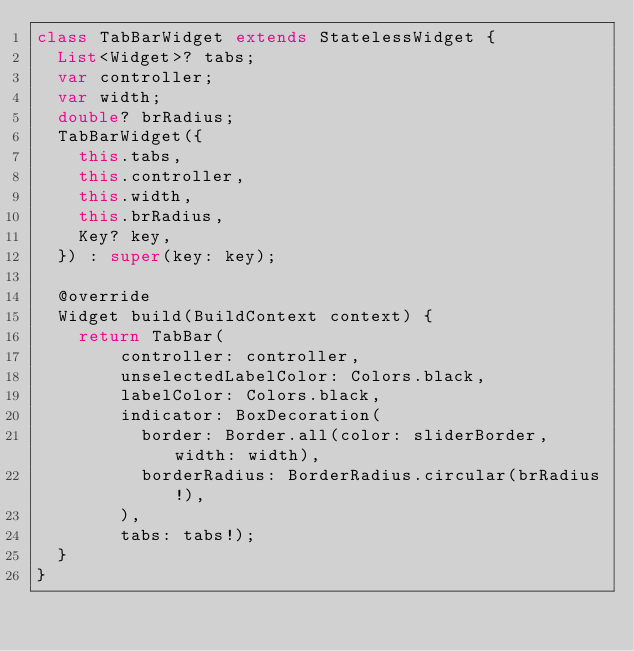Convert code to text. <code><loc_0><loc_0><loc_500><loc_500><_Dart_>class TabBarWidget extends StatelessWidget {
  List<Widget>? tabs;
  var controller;
  var width;
  double? brRadius;
  TabBarWidget({
    this.tabs,
    this.controller,
    this.width,
    this.brRadius,
    Key? key,
  }) : super(key: key);

  @override
  Widget build(BuildContext context) {
    return TabBar(
        controller: controller,
        unselectedLabelColor: Colors.black,
        labelColor: Colors.black,
        indicator: BoxDecoration(
          border: Border.all(color: sliderBorder, width: width),
          borderRadius: BorderRadius.circular(brRadius!),
        ),
        tabs: tabs!);
  }
}
</code> 